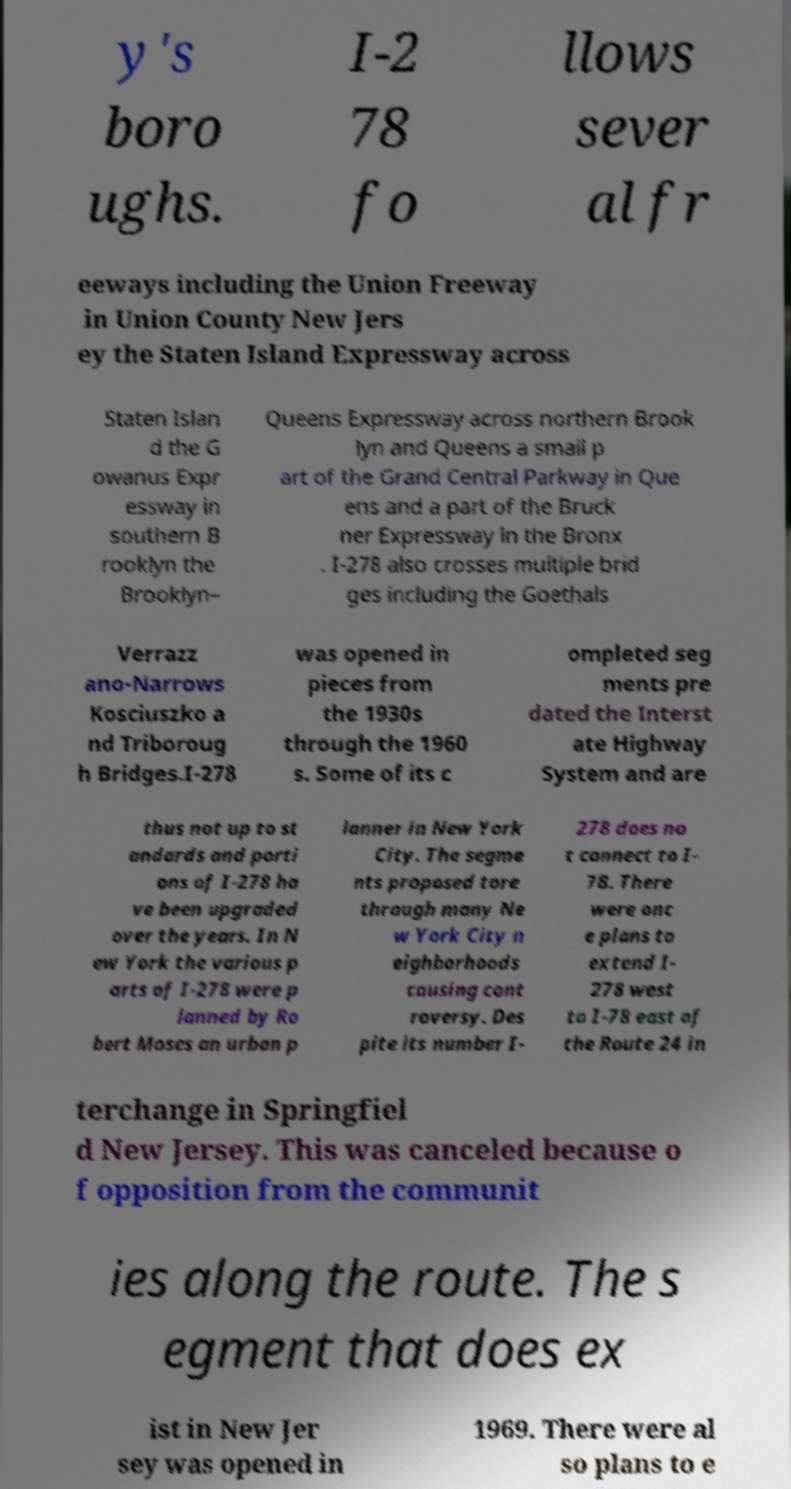I need the written content from this picture converted into text. Can you do that? y's boro ughs. I-2 78 fo llows sever al fr eeways including the Union Freeway in Union County New Jers ey the Staten Island Expressway across Staten Islan d the G owanus Expr essway in southern B rooklyn the Brooklyn– Queens Expressway across northern Brook lyn and Queens a small p art of the Grand Central Parkway in Que ens and a part of the Bruck ner Expressway in the Bronx . I-278 also crosses multiple brid ges including the Goethals Verrazz ano-Narrows Kosciuszko a nd Triboroug h Bridges.I-278 was opened in pieces from the 1930s through the 1960 s. Some of its c ompleted seg ments pre dated the Interst ate Highway System and are thus not up to st andards and porti ons of I-278 ha ve been upgraded over the years. In N ew York the various p arts of I-278 were p lanned by Ro bert Moses an urban p lanner in New York City. The segme nts proposed tore through many Ne w York City n eighborhoods causing cont roversy. Des pite its number I- 278 does no t connect to I- 78. There were onc e plans to extend I- 278 west to I-78 east of the Route 24 in terchange in Springfiel d New Jersey. This was canceled because o f opposition from the communit ies along the route. The s egment that does ex ist in New Jer sey was opened in 1969. There were al so plans to e 